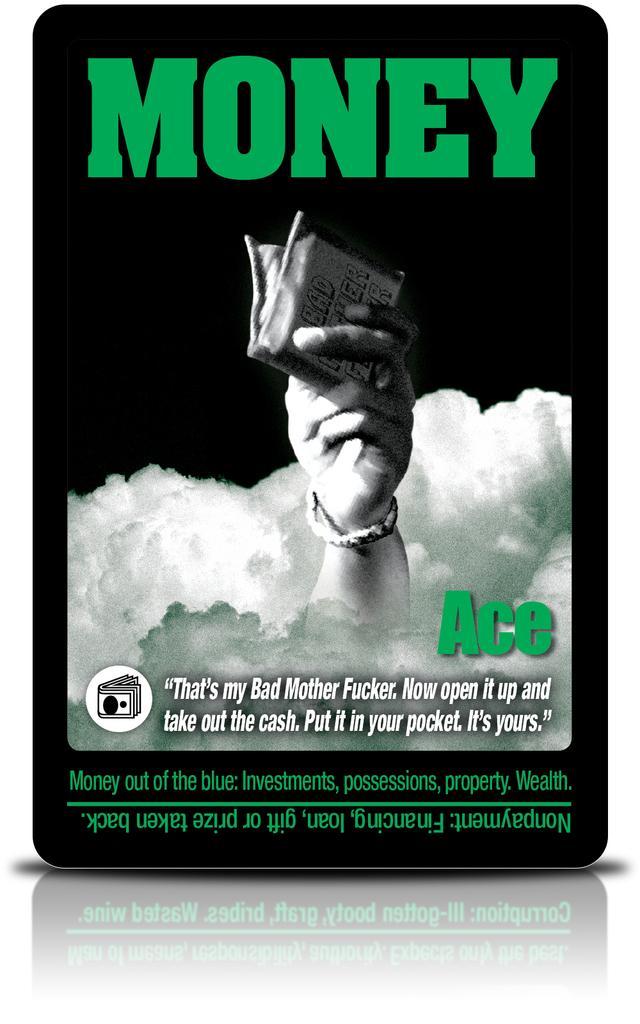Could you give a brief overview of what you see in this image? There is a poster, on which, there is a hand of a person holding an object, in the clouds, there is a quotation, and there are other texts and the background is dark in color. Outside this poster, the background is white in color. In front of this, there is a mirror image of the poster. 